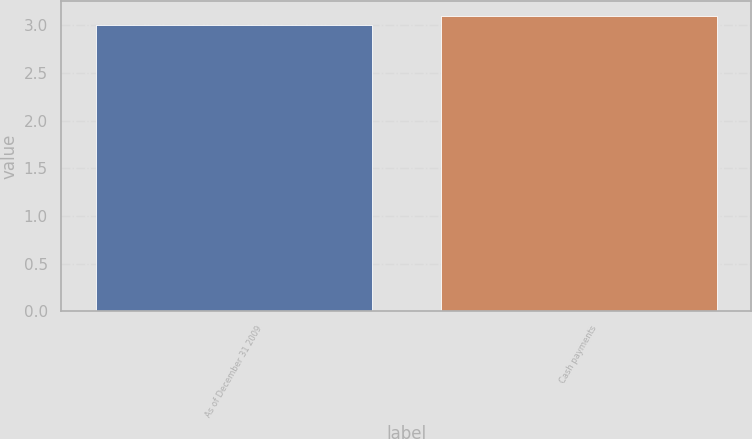<chart> <loc_0><loc_0><loc_500><loc_500><bar_chart><fcel>As of December 31 2009<fcel>Cash payments<nl><fcel>3<fcel>3.1<nl></chart> 